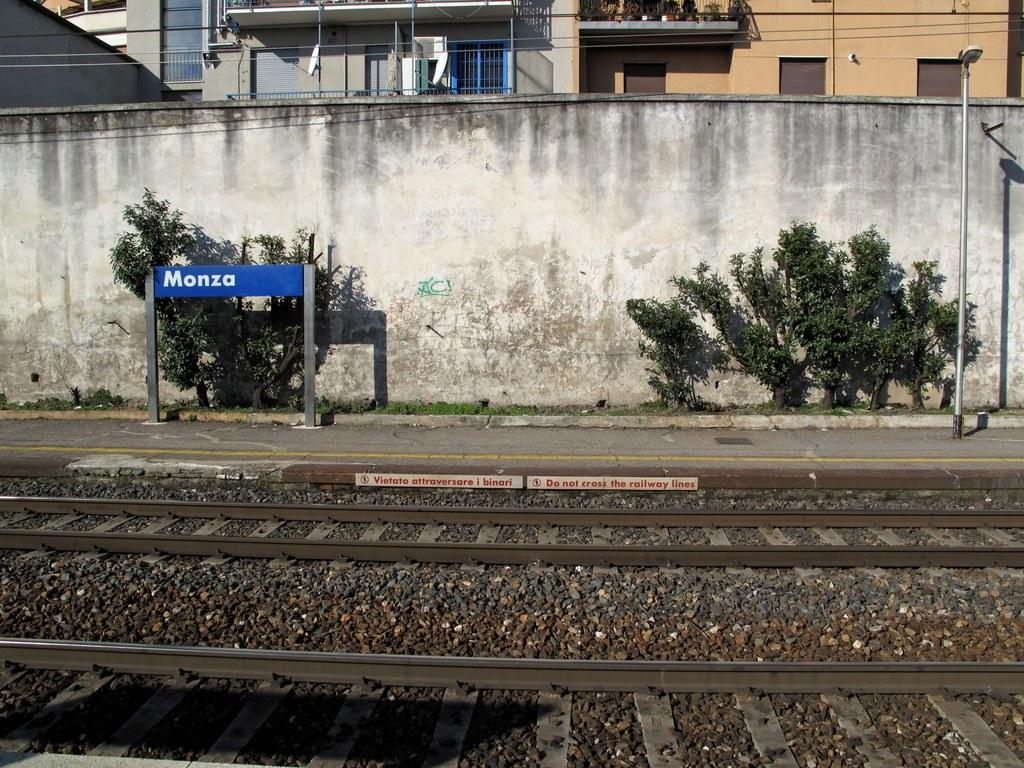What can be seen at the bottom of the image? At the bottom of the image, there are railway tracks, posters, text, and stones. What is located in the middle of the image? In the middle of the image, there are plants, a board, street lights, poles, buildings, windows, and a wall. Can you describe the buildings in the image? The buildings in the image have windows visible. What degree does the ghost in the image hold? There is no ghost present in the image. What industry does the wall in the image belong to? The wall in the image does not belong to any specific industry; it is a part of the buildings and surroundings depicted in the image. 